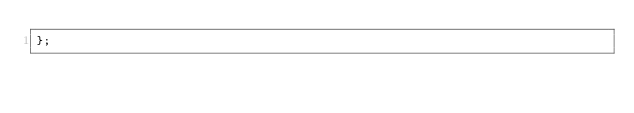<code> <loc_0><loc_0><loc_500><loc_500><_JavaScript_>};
</code> 